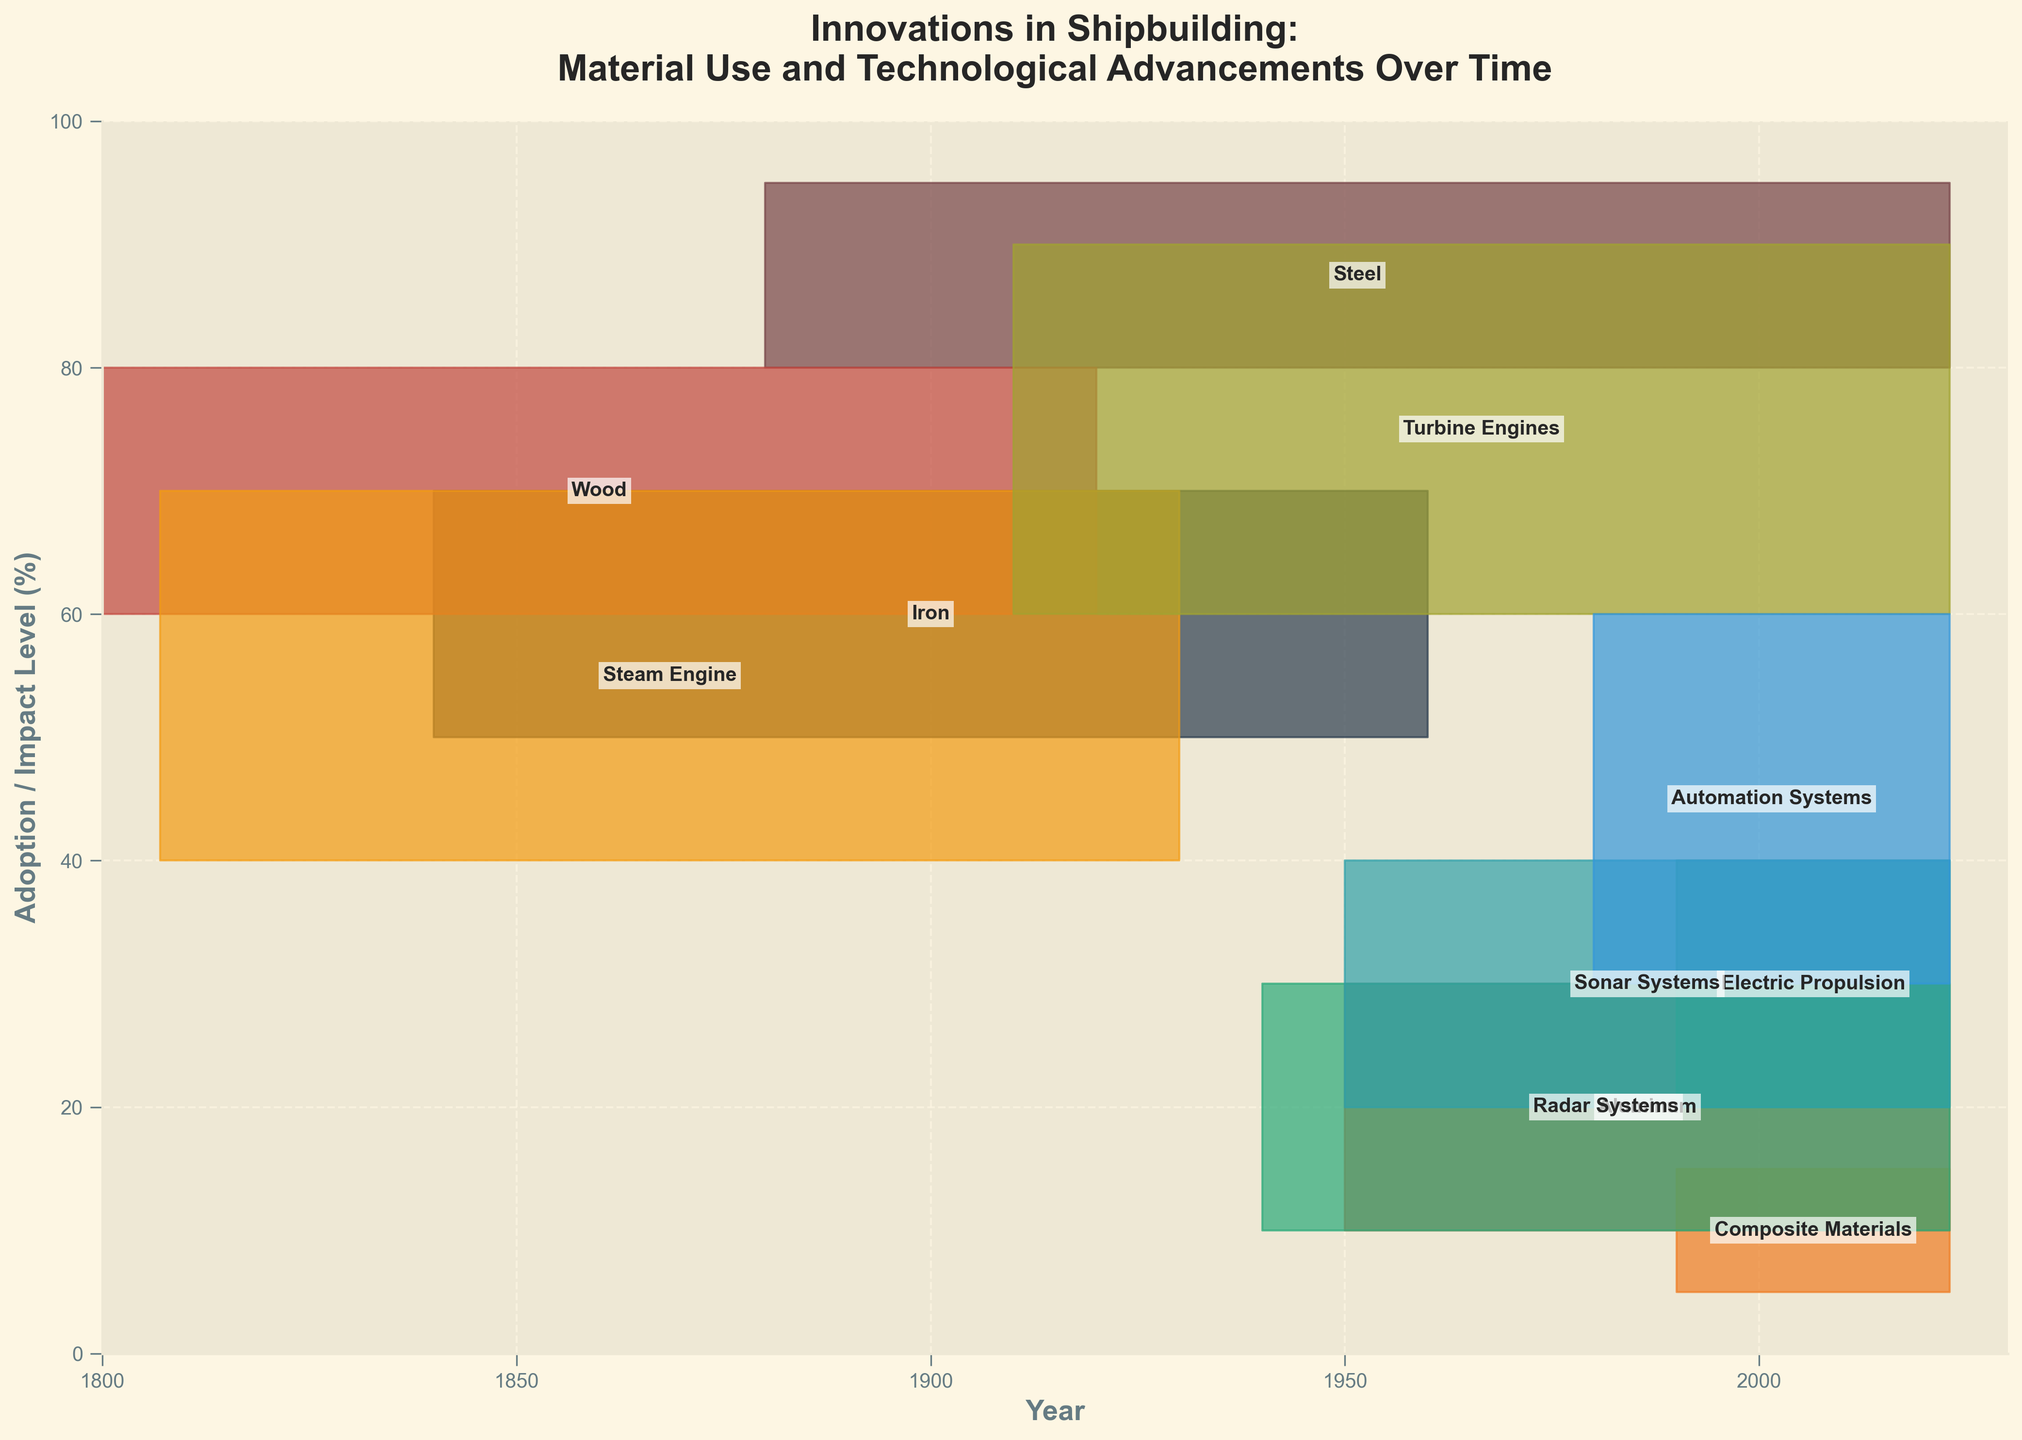What's the range of years for steel usage in shipbuilding? To find the range of years for steel usage, locate the starting and ending years of the steel segment on the horizontal axis.
Answer: 1880-2023 When did composite materials start to be used in shipbuilding? Observe the starting year for the composite materials segment on the horizontal axis.
Answer: 1990 Which material had the highest adoption/impact level at its peak? Identify the material that reaches the highest point on the vertical axis. Steel reaches from 80 to 95%.
Answer: Steel How long was wood used as a primary shipbuilding material? Calculate the difference between the end year and the start year for wood. 1920 - 1800 = 120 years.
Answer: 120 years What technological advancement began around 1910? Look for any innovation or advancement on the chart starting around 1910. Turbine Engines begin in 1910.
Answer: Turbine Engines Which material or technology had the largest range of adoption/impact levels? Compare the ranges of adoption levels for all materials/technologies. Steel has a range from 80 to 95.
Answer: Steel Compare the usage duration of the steam engine and electric propulsion. Which was used longer? Calculate the usage duration for both. Steam Engine: 1930 - 1807 = 123 years; Electric Propulsion: 2023 - 1990 = 33 years.
Answer: Steam Engine What is the primary material for shipbuilding after wood was phased out? Look at the period after wood’s phase-out and identify the predominant material. Steel is predominant after wood until current times.
Answer: Steel How did the adoption levels of radar systems and sonar systems compare? Compare the ranges and periods of adoption levels of radar and sonar systems. Both are adopted from 1940 and 1950 respectively, ranging from 10-30 for radar and 20-40 for sonar. Sonar has a slightly higher range.
Answer: Sonar Systems What advancement improved navigation and safety during transatlantic voyages? Locate the innovation associated with improvements in navigation and safety. Radar Systems is the relevant technological advancement.
Answer: Radar Systems 